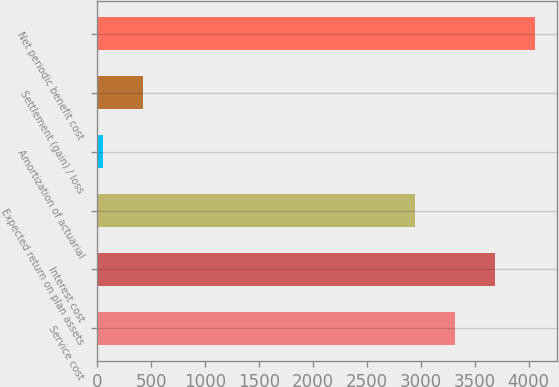Convert chart. <chart><loc_0><loc_0><loc_500><loc_500><bar_chart><fcel>Service cost<fcel>Interest cost<fcel>Expected return on plan assets<fcel>Amortization of actuarial<fcel>Settlement (gain) / loss<fcel>Net periodic benefit cost<nl><fcel>3319.8<fcel>3690.6<fcel>2949<fcel>54<fcel>424.8<fcel>4061.4<nl></chart> 